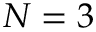<formula> <loc_0><loc_0><loc_500><loc_500>N = 3</formula> 